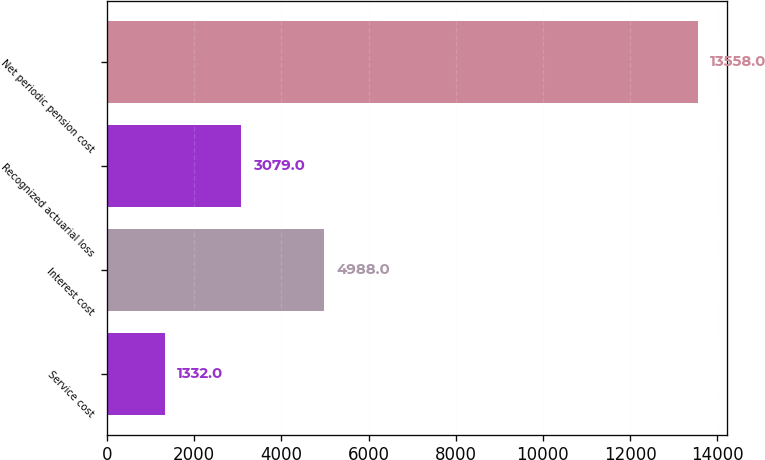Convert chart. <chart><loc_0><loc_0><loc_500><loc_500><bar_chart><fcel>Service cost<fcel>Interest cost<fcel>Recognized actuarial loss<fcel>Net periodic pension cost<nl><fcel>1332<fcel>4988<fcel>3079<fcel>13558<nl></chart> 